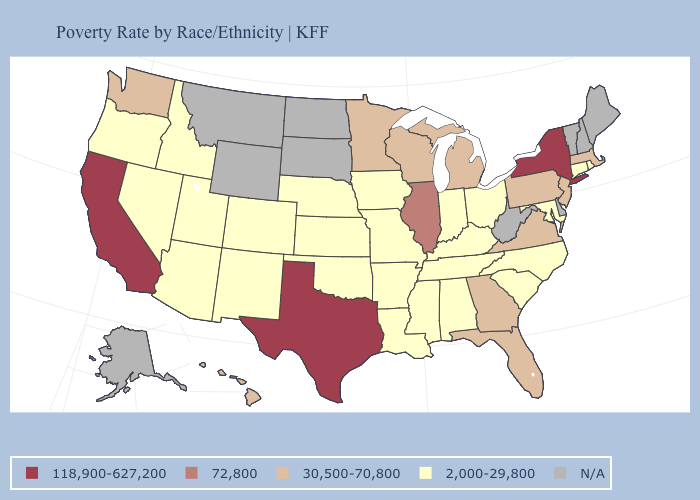What is the highest value in states that border Vermont?
Write a very short answer. 118,900-627,200. Does Wisconsin have the lowest value in the MidWest?
Answer briefly. No. How many symbols are there in the legend?
Give a very brief answer. 5. Among the states that border Massachusetts , which have the lowest value?
Answer briefly. Connecticut, Rhode Island. Name the states that have a value in the range 72,800?
Concise answer only. Illinois. Name the states that have a value in the range 118,900-627,200?
Quick response, please. California, New York, Texas. Which states have the lowest value in the Northeast?
Be succinct. Connecticut, Rhode Island. What is the highest value in the USA?
Short answer required. 118,900-627,200. Which states have the lowest value in the West?
Answer briefly. Arizona, Colorado, Idaho, Nevada, New Mexico, Oregon, Utah. Name the states that have a value in the range 30,500-70,800?
Concise answer only. Florida, Georgia, Hawaii, Massachusetts, Michigan, Minnesota, New Jersey, Pennsylvania, Virginia, Washington, Wisconsin. Which states have the lowest value in the USA?
Short answer required. Alabama, Arizona, Arkansas, Colorado, Connecticut, Idaho, Indiana, Iowa, Kansas, Kentucky, Louisiana, Maryland, Mississippi, Missouri, Nebraska, Nevada, New Mexico, North Carolina, Ohio, Oklahoma, Oregon, Rhode Island, South Carolina, Tennessee, Utah. Name the states that have a value in the range N/A?
Keep it brief. Alaska, Delaware, Maine, Montana, New Hampshire, North Dakota, South Dakota, Vermont, West Virginia, Wyoming. Among the states that border Oklahoma , which have the highest value?
Keep it brief. Texas. Does Rhode Island have the highest value in the Northeast?
Give a very brief answer. No. How many symbols are there in the legend?
Give a very brief answer. 5. 